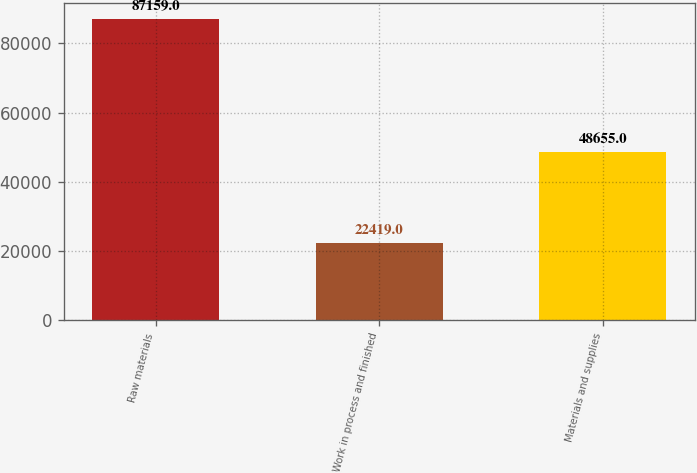Convert chart. <chart><loc_0><loc_0><loc_500><loc_500><bar_chart><fcel>Raw materials<fcel>Work in process and finished<fcel>Materials and supplies<nl><fcel>87159<fcel>22419<fcel>48655<nl></chart> 